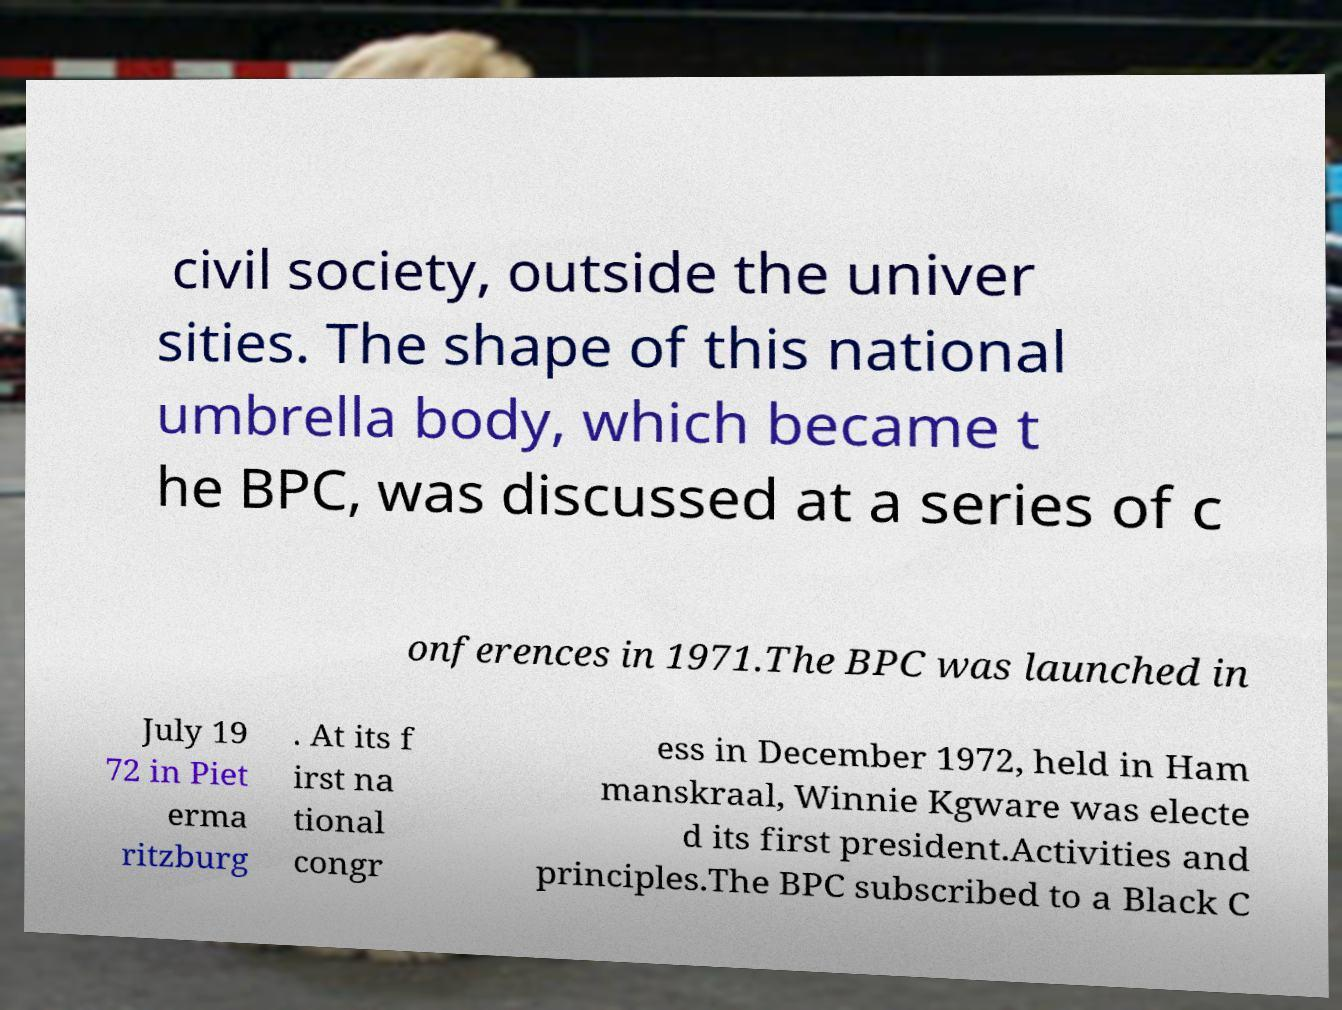What messages or text are displayed in this image? I need them in a readable, typed format. civil society, outside the univer sities. The shape of this national umbrella body, which became t he BPC, was discussed at a series of c onferences in 1971.The BPC was launched in July 19 72 in Piet erma ritzburg . At its f irst na tional congr ess in December 1972, held in Ham manskraal, Winnie Kgware was electe d its first president.Activities and principles.The BPC subscribed to a Black C 